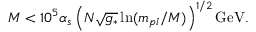Convert formula to latex. <formula><loc_0><loc_0><loc_500><loc_500>M < 1 0 ^ { 5 } \alpha _ { s } \left ( N \sqrt { g _ { * } } \ln ( m _ { p l } / M ) \right ) ^ { 1 / 2 } G e V .</formula> 